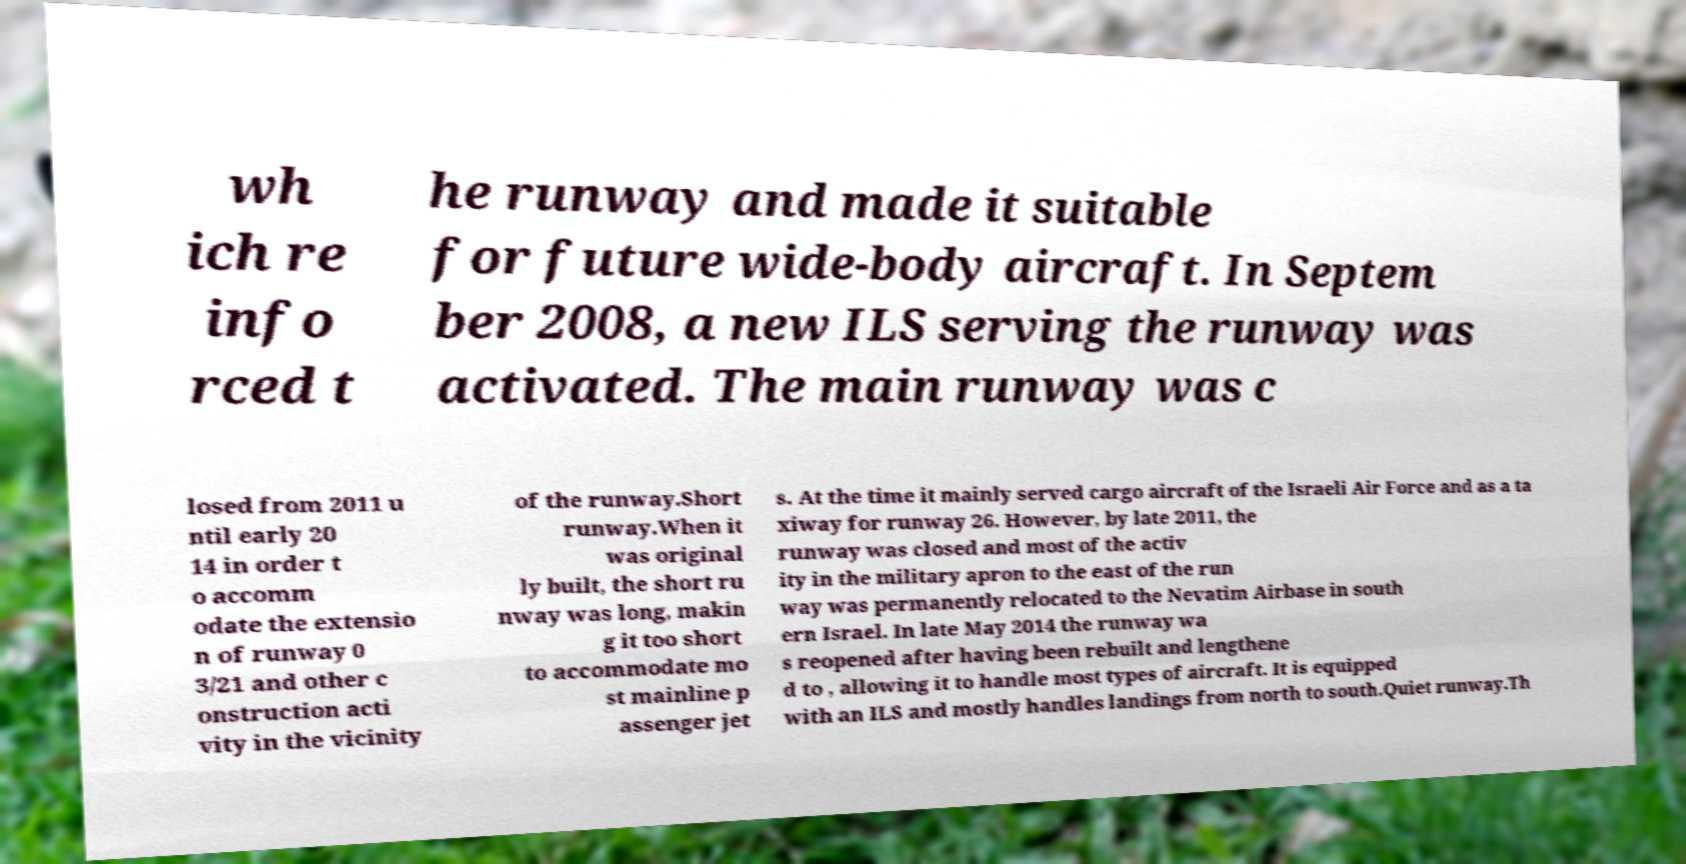Could you assist in decoding the text presented in this image and type it out clearly? wh ich re info rced t he runway and made it suitable for future wide-body aircraft. In Septem ber 2008, a new ILS serving the runway was activated. The main runway was c losed from 2011 u ntil early 20 14 in order t o accomm odate the extensio n of runway 0 3/21 and other c onstruction acti vity in the vicinity of the runway.Short runway.When it was original ly built, the short ru nway was long, makin g it too short to accommodate mo st mainline p assenger jet s. At the time it mainly served cargo aircraft of the Israeli Air Force and as a ta xiway for runway 26. However, by late 2011, the runway was closed and most of the activ ity in the military apron to the east of the run way was permanently relocated to the Nevatim Airbase in south ern Israel. In late May 2014 the runway wa s reopened after having been rebuilt and lengthene d to , allowing it to handle most types of aircraft. It is equipped with an ILS and mostly handles landings from north to south.Quiet runway.Th 